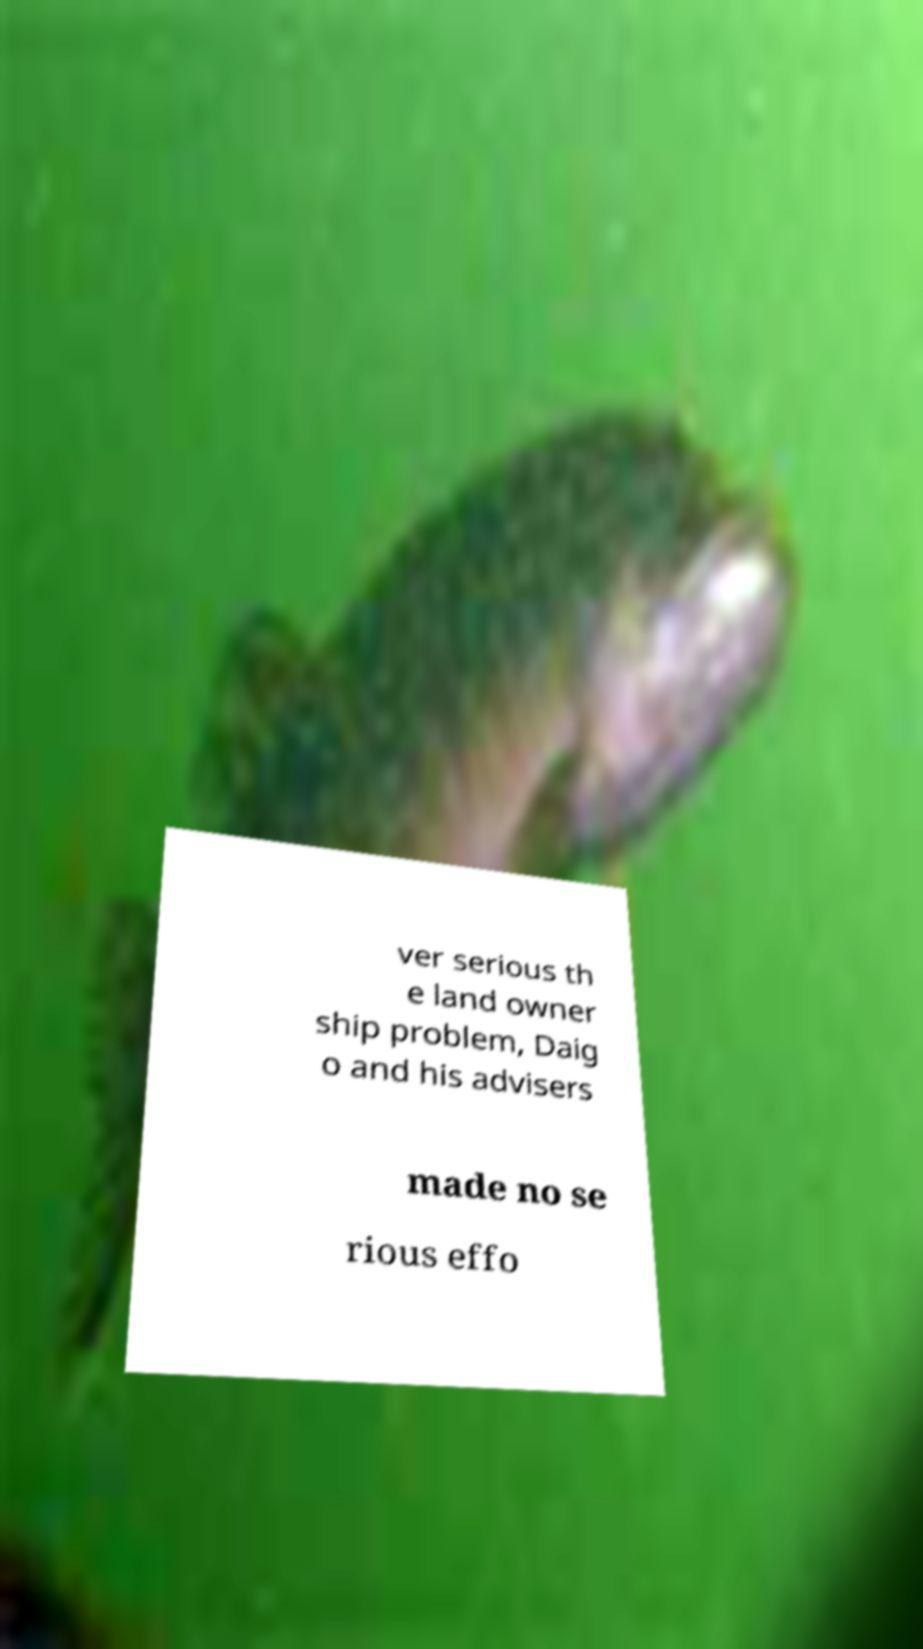Could you assist in decoding the text presented in this image and type it out clearly? ver serious th e land owner ship problem, Daig o and his advisers made no se rious effo 